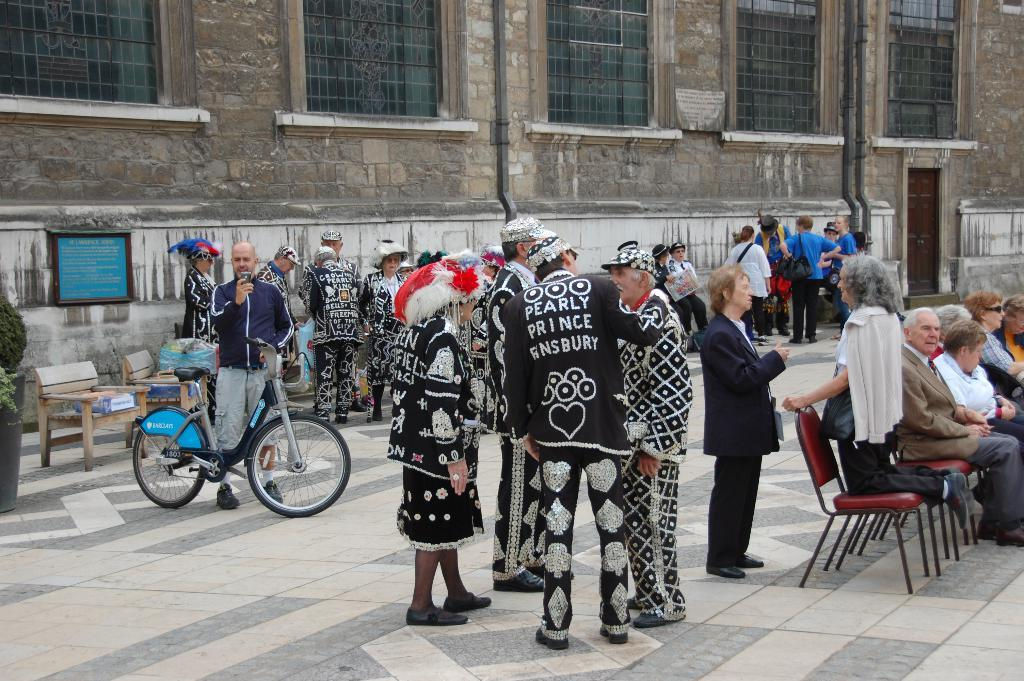What is the main subject of the image? The main subject of the image is a group of people. Can you describe the man in the image? The man is standing with a bicycle. What can be seen in the background of the image? There is a building visible in the background. What flavor of ice cream is the man holding in the image? There is no ice cream present in the image; the man is standing with a bicycle. What type of structure is the afterthought in the image? There is no structure or afterthought mentioned in the image; it features a group of people, a man with a bicycle, and a building in the background. 